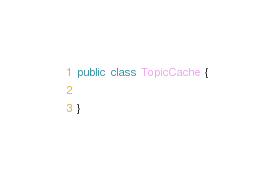Convert code to text. <code><loc_0><loc_0><loc_500><loc_500><_Java_>public class TopicCache {

}
</code> 